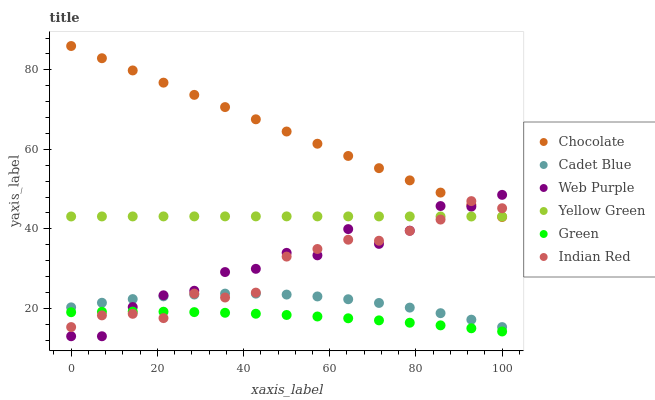Does Green have the minimum area under the curve?
Answer yes or no. Yes. Does Chocolate have the maximum area under the curve?
Answer yes or no. Yes. Does Yellow Green have the minimum area under the curve?
Answer yes or no. No. Does Yellow Green have the maximum area under the curve?
Answer yes or no. No. Is Chocolate the smoothest?
Answer yes or no. Yes. Is Web Purple the roughest?
Answer yes or no. Yes. Is Yellow Green the smoothest?
Answer yes or no. No. Is Yellow Green the roughest?
Answer yes or no. No. Does Web Purple have the lowest value?
Answer yes or no. Yes. Does Chocolate have the lowest value?
Answer yes or no. No. Does Chocolate have the highest value?
Answer yes or no. Yes. Does Yellow Green have the highest value?
Answer yes or no. No. Is Cadet Blue less than Yellow Green?
Answer yes or no. Yes. Is Cadet Blue greater than Green?
Answer yes or no. Yes. Does Indian Red intersect Yellow Green?
Answer yes or no. Yes. Is Indian Red less than Yellow Green?
Answer yes or no. No. Is Indian Red greater than Yellow Green?
Answer yes or no. No. Does Cadet Blue intersect Yellow Green?
Answer yes or no. No. 